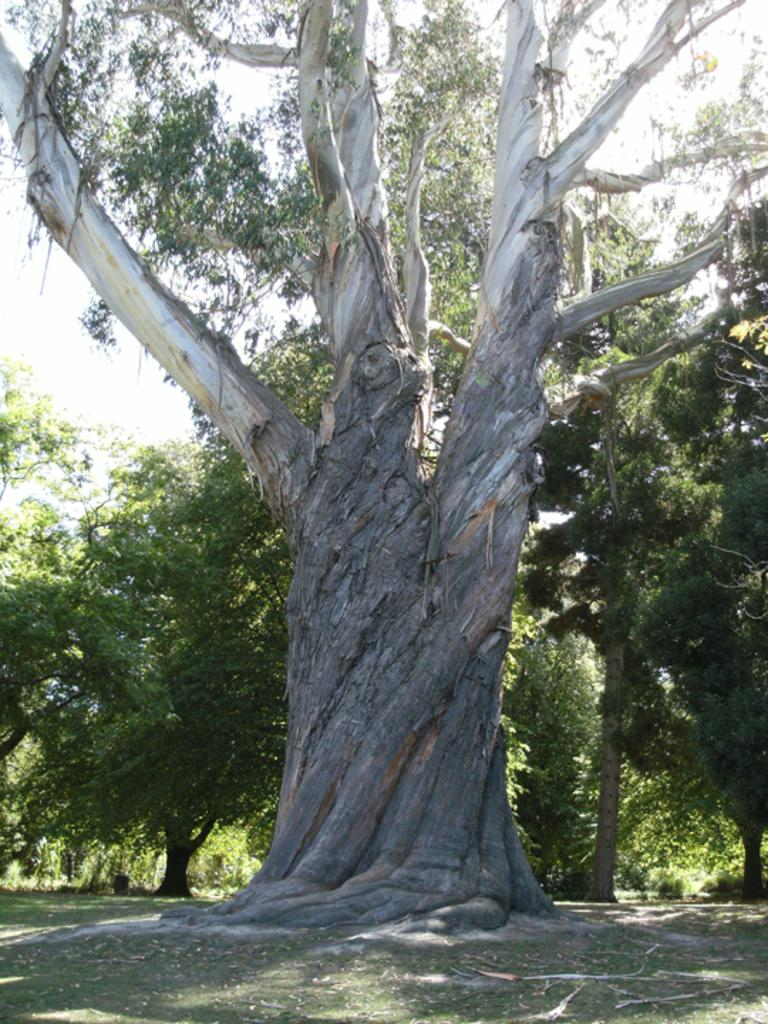What object is the main focus of the image? There is a trunk in the image. What can be seen in the background of the image? There are trees and the sky visible in the background of the image. What is the color of the trees in the image? The trees are green in the image. What is the color of the sky in the image? The sky is white in color in the image. Can you see the quiver hanging on the trunk in the image? There is no quiver present in the image. Is the aunt holding a fork while standing next to the trunk in the image? There is no aunt or fork present in the image. 